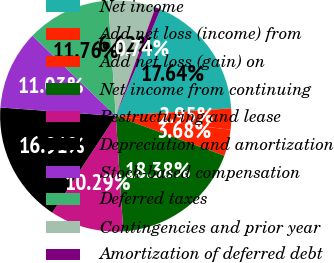Convert chart to OTSL. <chart><loc_0><loc_0><loc_500><loc_500><pie_chart><fcel>Net income<fcel>Add net loss (income) from<fcel>Add net loss (gain) on<fcel>Net income from continuing<fcel>Restructuring and lease<fcel>Depreciation and amortization<fcel>Stock-based compensation<fcel>Deferred taxes<fcel>Contingencies and prior year<fcel>Amortization of deferred debt<nl><fcel>17.64%<fcel>2.95%<fcel>3.68%<fcel>18.38%<fcel>10.29%<fcel>16.91%<fcel>11.03%<fcel>11.76%<fcel>6.62%<fcel>0.74%<nl></chart> 